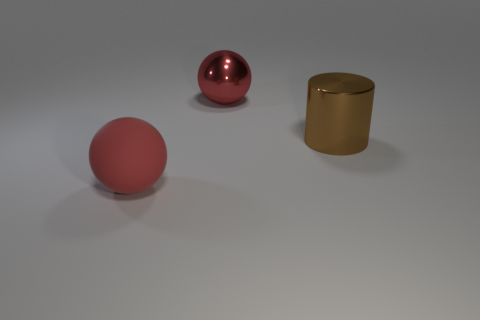Can you describe the lighting and shadows visible in the image? The image shows soft lighting with diffuse shadows, suggesting a source of light that's probably not in the direct line of sight. The shadows are elongated, indicating the light is coming from the upper left, somewhat consistent across all objects, which adds to the scene's uniformity. 